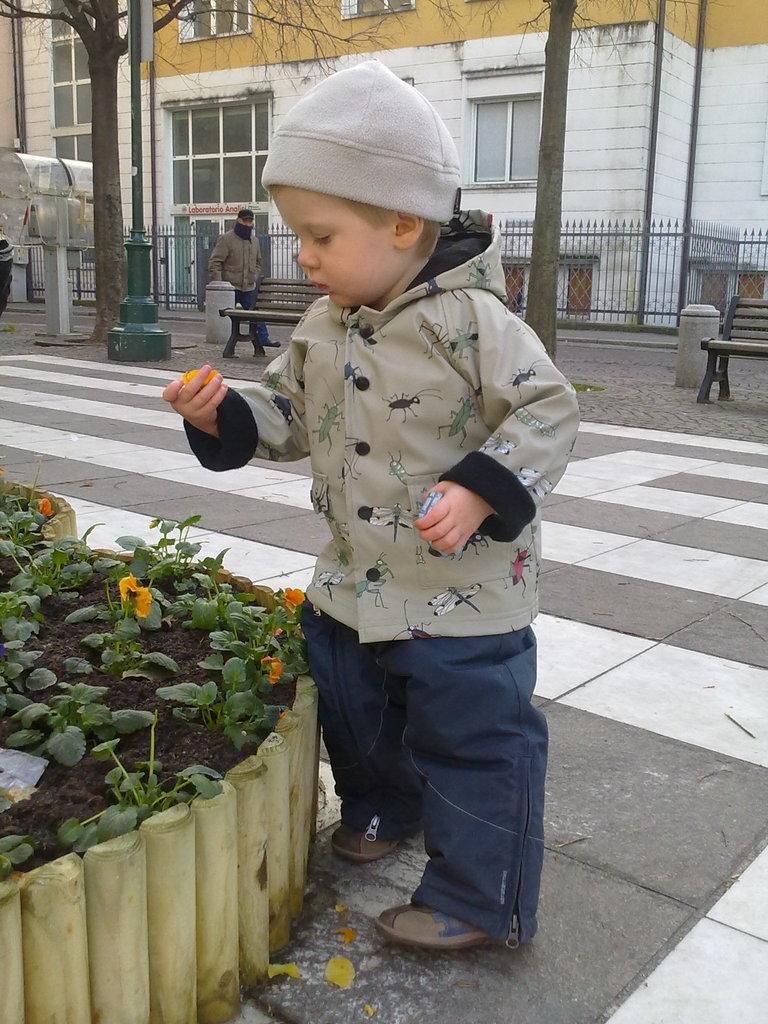In one or two sentences, can you explain what this image depicts? This picture shows kid holding the flower, near a small plants. He is wearing a hoodie. In the Background, there is a bench and a man walking her. We can observe a tree and buildings here. 